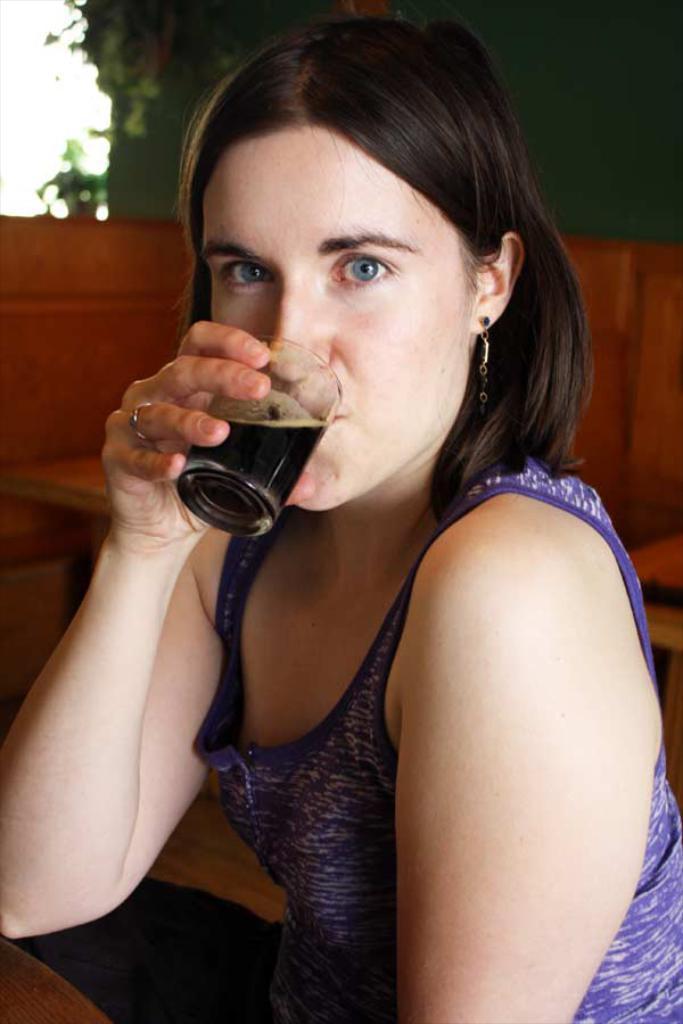In one or two sentences, can you explain what this image depicts? In this image there is a woman having a drink. 